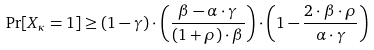<formula> <loc_0><loc_0><loc_500><loc_500>\Pr [ X _ { \kappa } = 1 ] \geq ( 1 - \gamma ) \cdot \left ( \frac { \beta - \alpha \cdot \gamma } { ( 1 + \rho ) \cdot \beta } \right ) \cdot \left ( 1 - \frac { 2 \cdot \beta \cdot \rho } { \alpha \cdot \gamma } \right )</formula> 